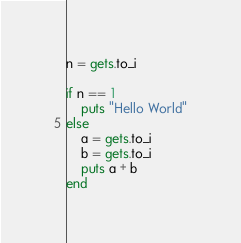Convert code to text. <code><loc_0><loc_0><loc_500><loc_500><_Ruby_>n = gets.to_i

if n == 1
    puts "Hello World"
else
    a = gets.to_i
    b = gets.to_i
    puts a + b
end
</code> 